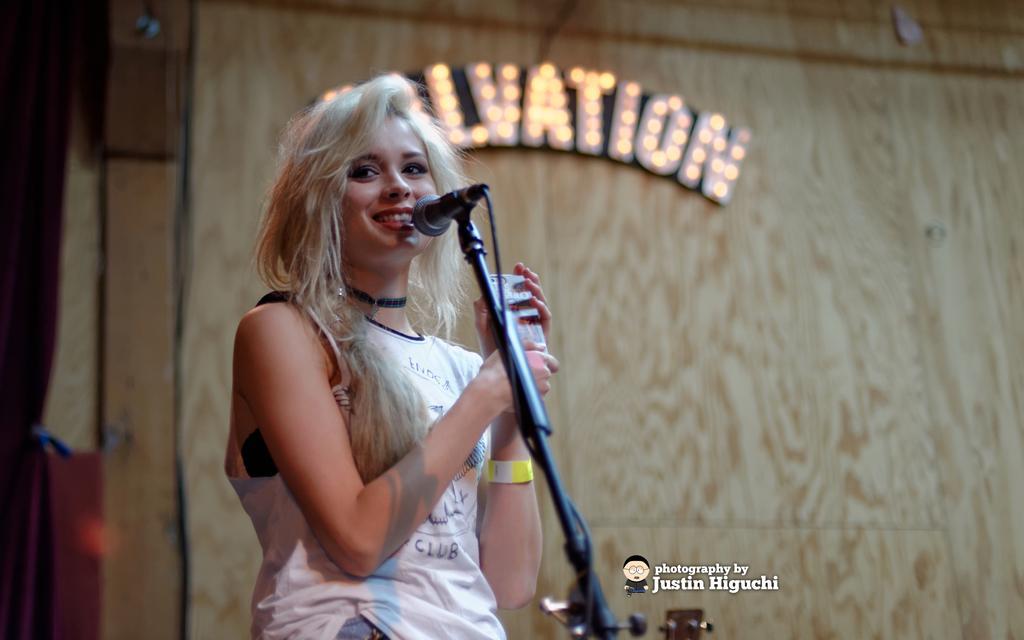Please provide a concise description of this image. In this image I can see a woman who is standing in front of a mic and I see that she is smiling and she is holding phone in her hands and I see the watermark over here. In the background I see the wall and I see a word written over here and I see lights on it. 